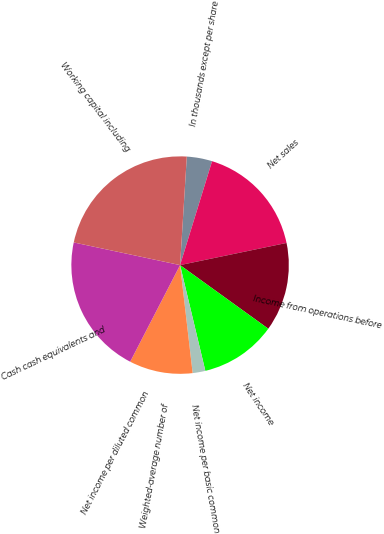Convert chart to OTSL. <chart><loc_0><loc_0><loc_500><loc_500><pie_chart><fcel>In thousands except per share<fcel>Net sales<fcel>Income from operations before<fcel>Net income<fcel>Net income per basic common<fcel>Weighted-average number of<fcel>Net income per diluted common<fcel>Cash cash equivalents and<fcel>Working capital including<nl><fcel>3.77%<fcel>16.98%<fcel>13.21%<fcel>11.32%<fcel>1.89%<fcel>9.43%<fcel>0.0%<fcel>20.75%<fcel>22.64%<nl></chart> 